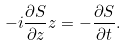<formula> <loc_0><loc_0><loc_500><loc_500>- i \frac { \partial S } { \partial z } z = - \frac { \partial S } { \partial t } .</formula> 